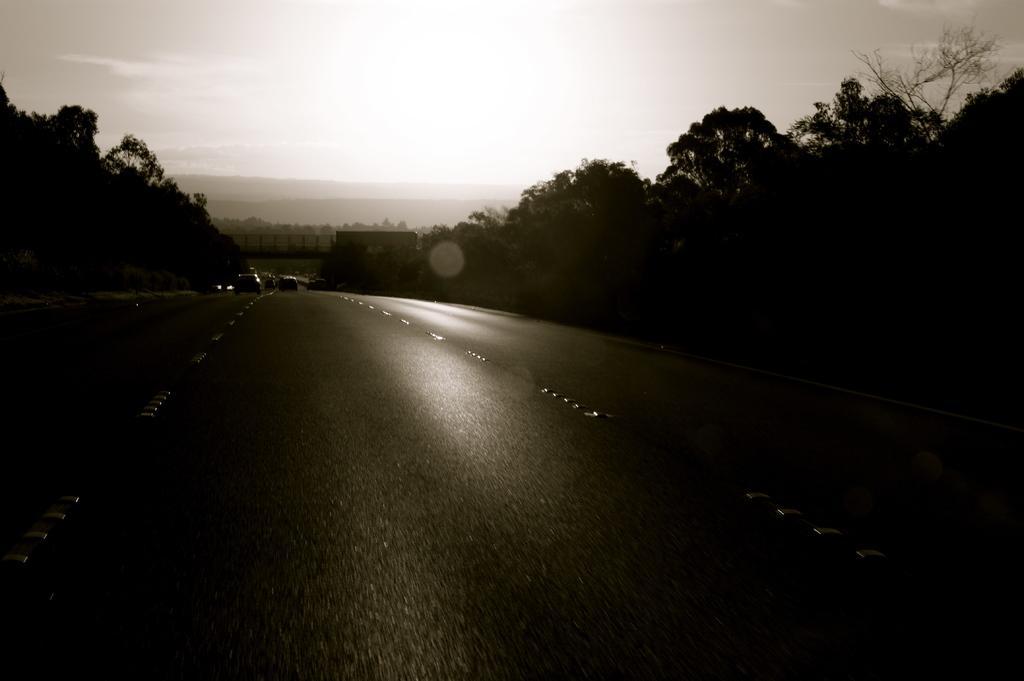In one or two sentences, can you explain what this image depicts? In this picture, we see vehicles moving on the road. On either side of the road, we see trees. At the top of the picture, we see the sky and sun. This is a black and white picture and this picture is clicked outside the city. 